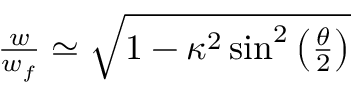Convert formula to latex. <formula><loc_0><loc_0><loc_500><loc_500>\begin{array} { r } { \frac { w } { w _ { f } } \simeq \sqrt { 1 - \kappa ^ { 2 } \sin ^ { 2 } \left ( \frac { \theta } { 2 } \right ) } } \end{array}</formula> 